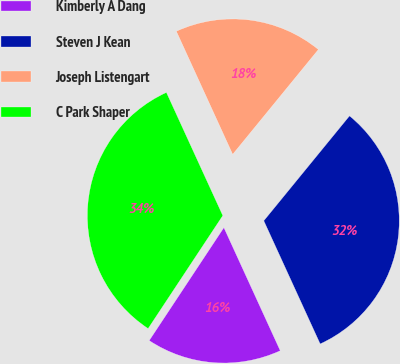Convert chart to OTSL. <chart><loc_0><loc_0><loc_500><loc_500><pie_chart><fcel>Kimberly A Dang<fcel>Steven J Kean<fcel>Joseph Listengart<fcel>C Park Shaper<nl><fcel>16.13%<fcel>32.26%<fcel>17.74%<fcel>33.87%<nl></chart> 